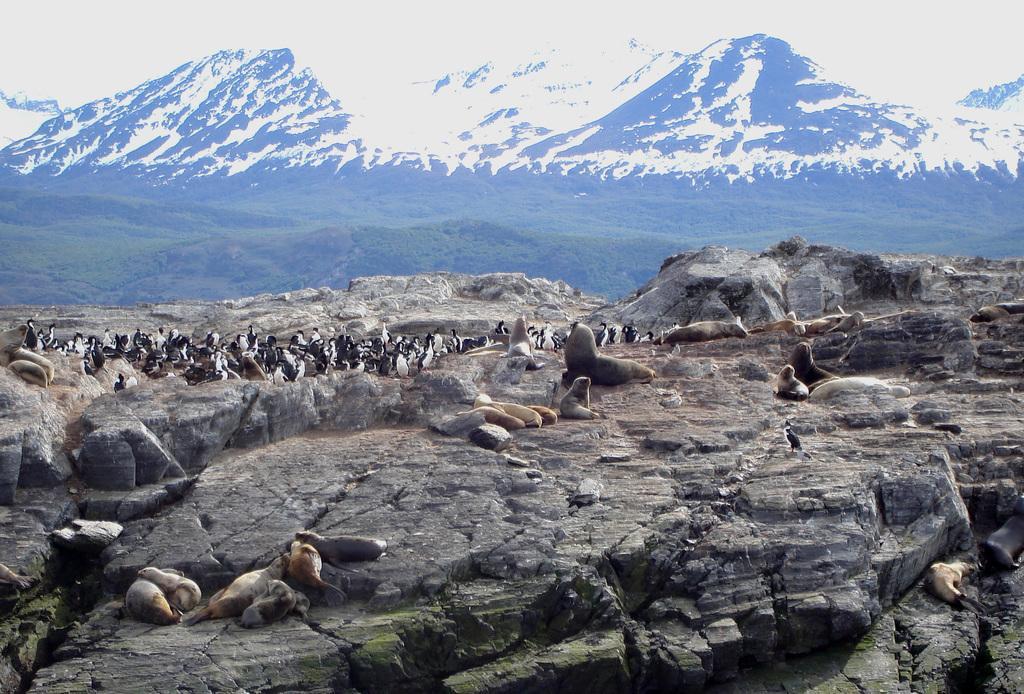Please provide a concise description of this image. In this image there are some seal animals at bottom left side of this image and middle of this image and right side of this image as well and there are big mountains at top of the image and there are some penguins at middle of this image and there are two other seal animals at bottom right side of this image. 